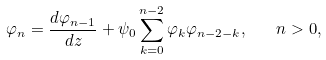Convert formula to latex. <formula><loc_0><loc_0><loc_500><loc_500>\varphi _ { n } = \frac { d \varphi _ { n - 1 } } { d z } + \psi _ { 0 } \sum _ { k = 0 } ^ { n - 2 } \varphi _ { k } \varphi _ { n - 2 - k } , \quad n > 0 ,</formula> 